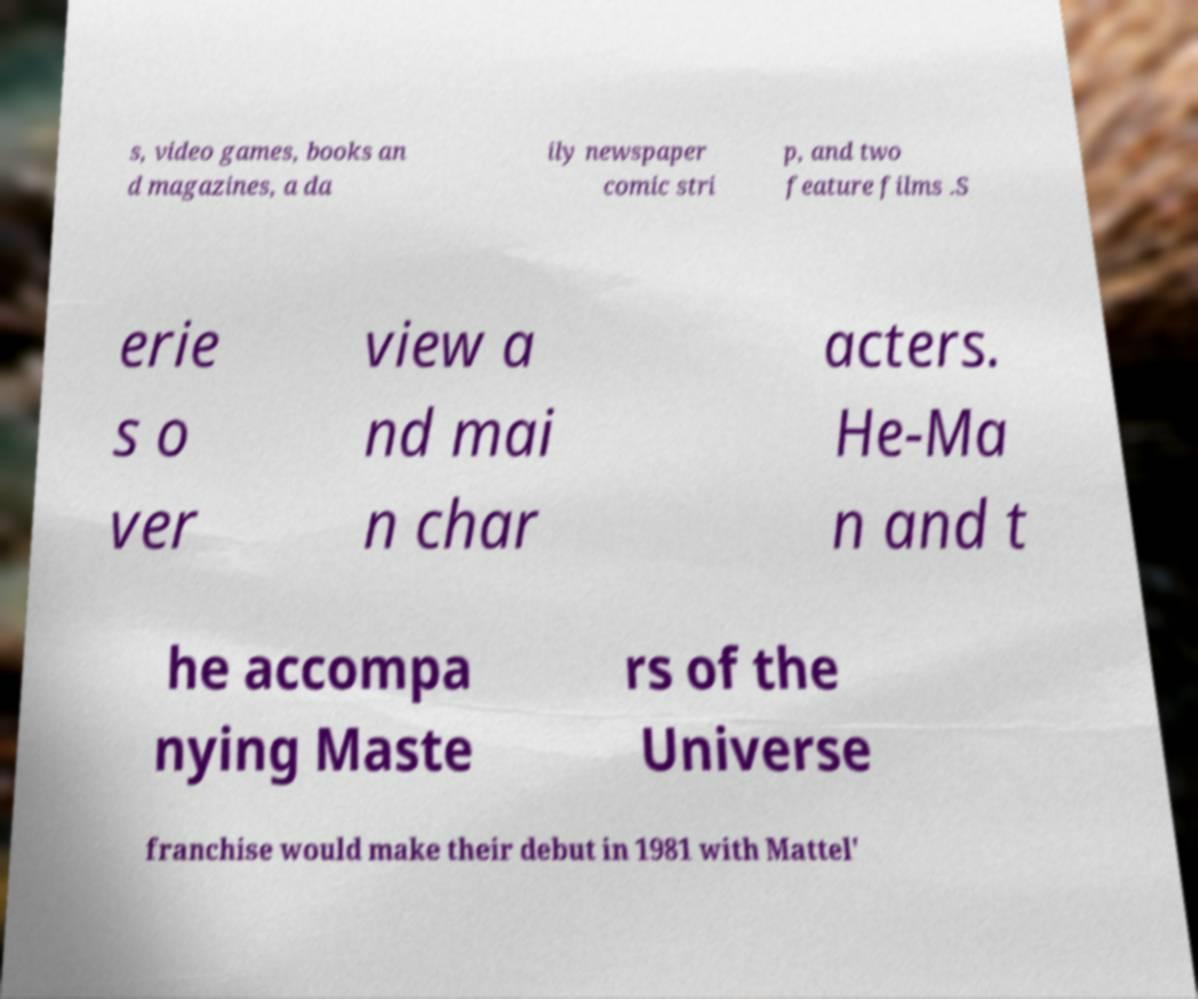For documentation purposes, I need the text within this image transcribed. Could you provide that? s, video games, books an d magazines, a da ily newspaper comic stri p, and two feature films .S erie s o ver view a nd mai n char acters. He-Ma n and t he accompa nying Maste rs of the Universe franchise would make their debut in 1981 with Mattel' 